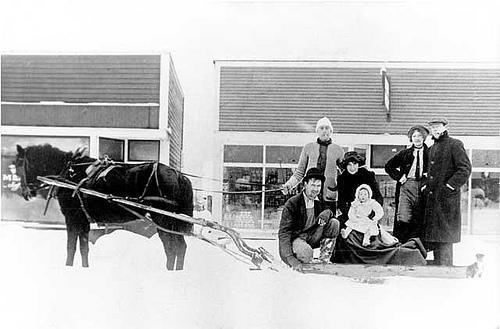How many babies are in the picture?
Give a very brief answer. 1. 